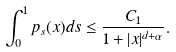Convert formula to latex. <formula><loc_0><loc_0><loc_500><loc_500>\int ^ { 1 } _ { 0 } p _ { s } ( x ) d s \leq \frac { C _ { 1 } } { 1 + | x | ^ { d + \alpha } } .</formula> 